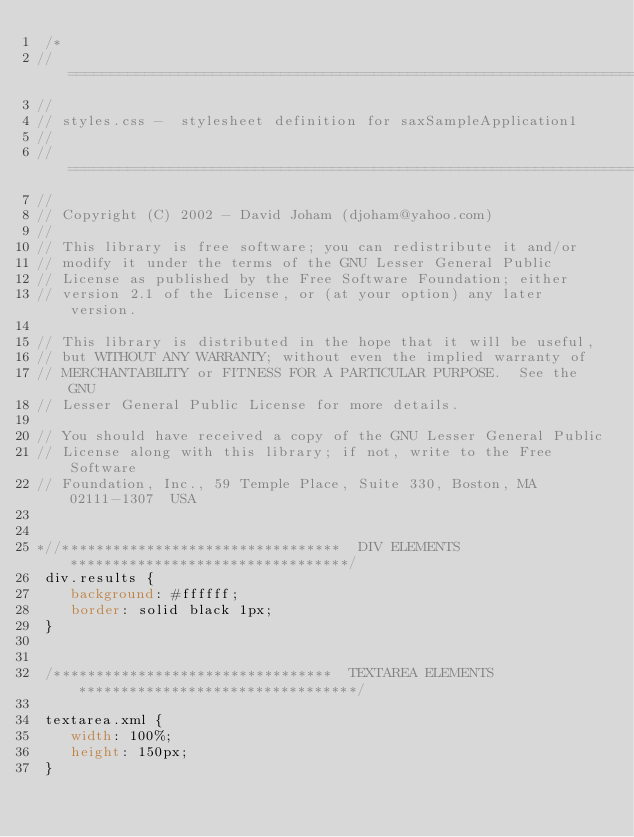Convert code to text. <code><loc_0><loc_0><loc_500><loc_500><_CSS_> /*
// =========================================================================
//
// styles.css -  stylesheet definition for saxSampleApplication1
//
// =========================================================================
//
// Copyright (C) 2002 - David Joham (djoham@yahoo.com)
//
// This library is free software; you can redistribute it and/or
// modify it under the terms of the GNU Lesser General Public
// License as published by the Free Software Foundation; either
// version 2.1 of the License, or (at your option) any later version.

// This library is distributed in the hope that it will be useful,
// but WITHOUT ANY WARRANTY; without even the implied warranty of
// MERCHANTABILITY or FITNESS FOR A PARTICULAR PURPOSE.  See the GNU
// Lesser General Public License for more details.

// You should have received a copy of the GNU Lesser General Public
// License along with this library; if not, write to the Free Software
// Foundation, Inc., 59 Temple Place, Suite 330, Boston, MA  02111-1307  USA


*//*********************************  DIV ELEMENTS  *********************************/
 div.results {
    background: #ffffff;
    border: solid black 1px;
 }


 /*********************************  TEXTAREA ELEMENTS  *********************************/

 textarea.xml {
    width: 100%;
    height: 150px;
 }
</code> 